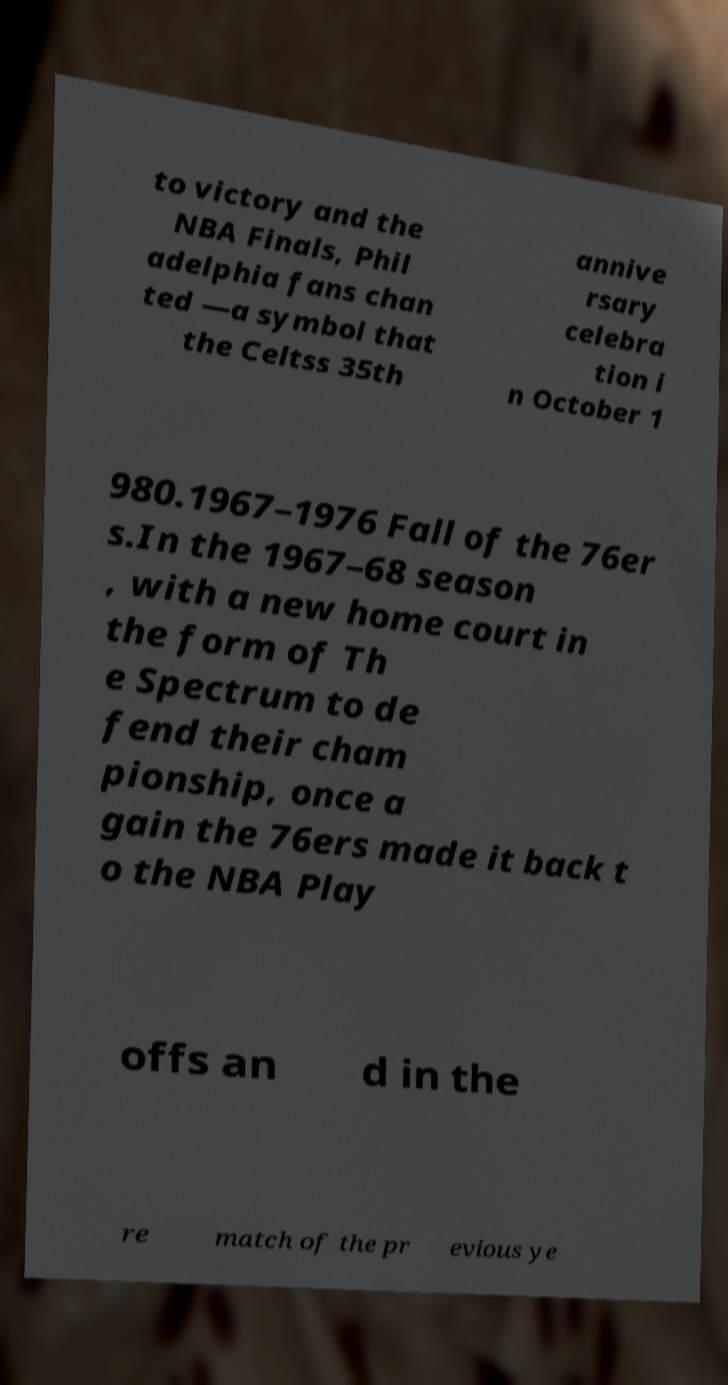There's text embedded in this image that I need extracted. Can you transcribe it verbatim? to victory and the NBA Finals, Phil adelphia fans chan ted —a symbol that the Celtss 35th annive rsary celebra tion i n October 1 980.1967–1976 Fall of the 76er s.In the 1967–68 season , with a new home court in the form of Th e Spectrum to de fend their cham pionship, once a gain the 76ers made it back t o the NBA Play offs an d in the re match of the pr evious ye 